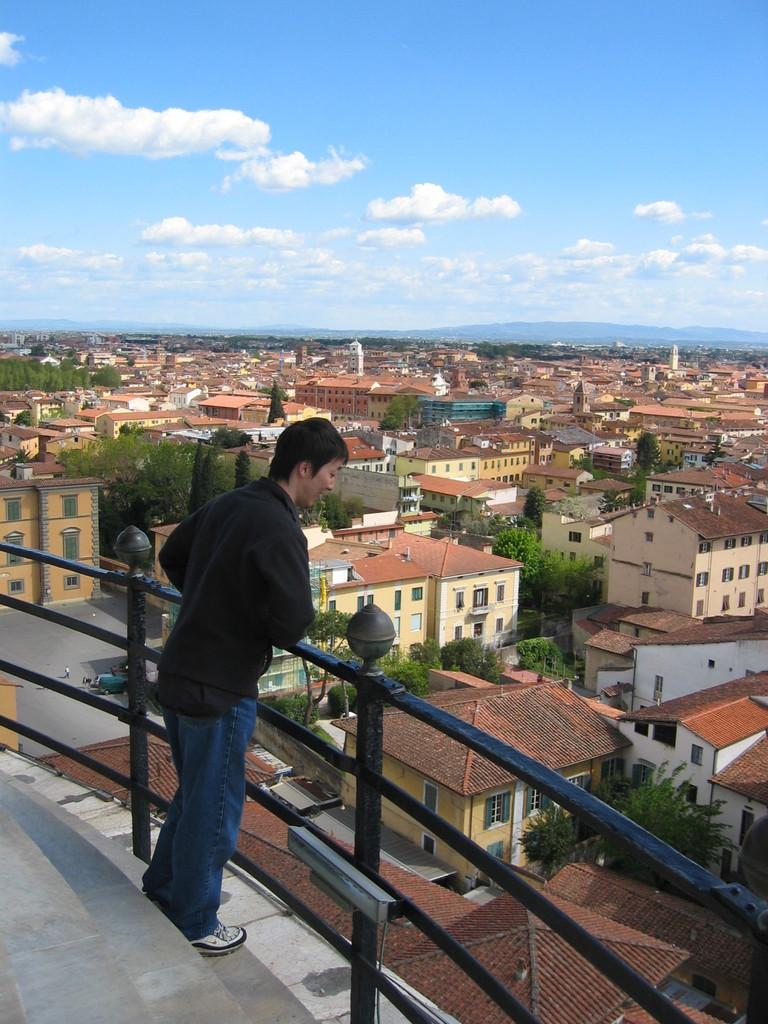What type of structure can be seen in the image? There are steps, a fence, buildings, and trees visible in the image. Can you describe the person in the image? There is a person in the image, but no specific details about their appearance or actions are provided. What is the background of the image like? In the background, there are mountains, the sky, and clouds visible. What objects can be seen in the image? The provided facts mention that there are objects in the image, but no specific details are given about them. What advice does the person in the image give to the viewer? There is no indication in the image that the person is giving advice to the viewer. What is the smell of the trees in the image? The image does not provide any information about the smell of the trees. 